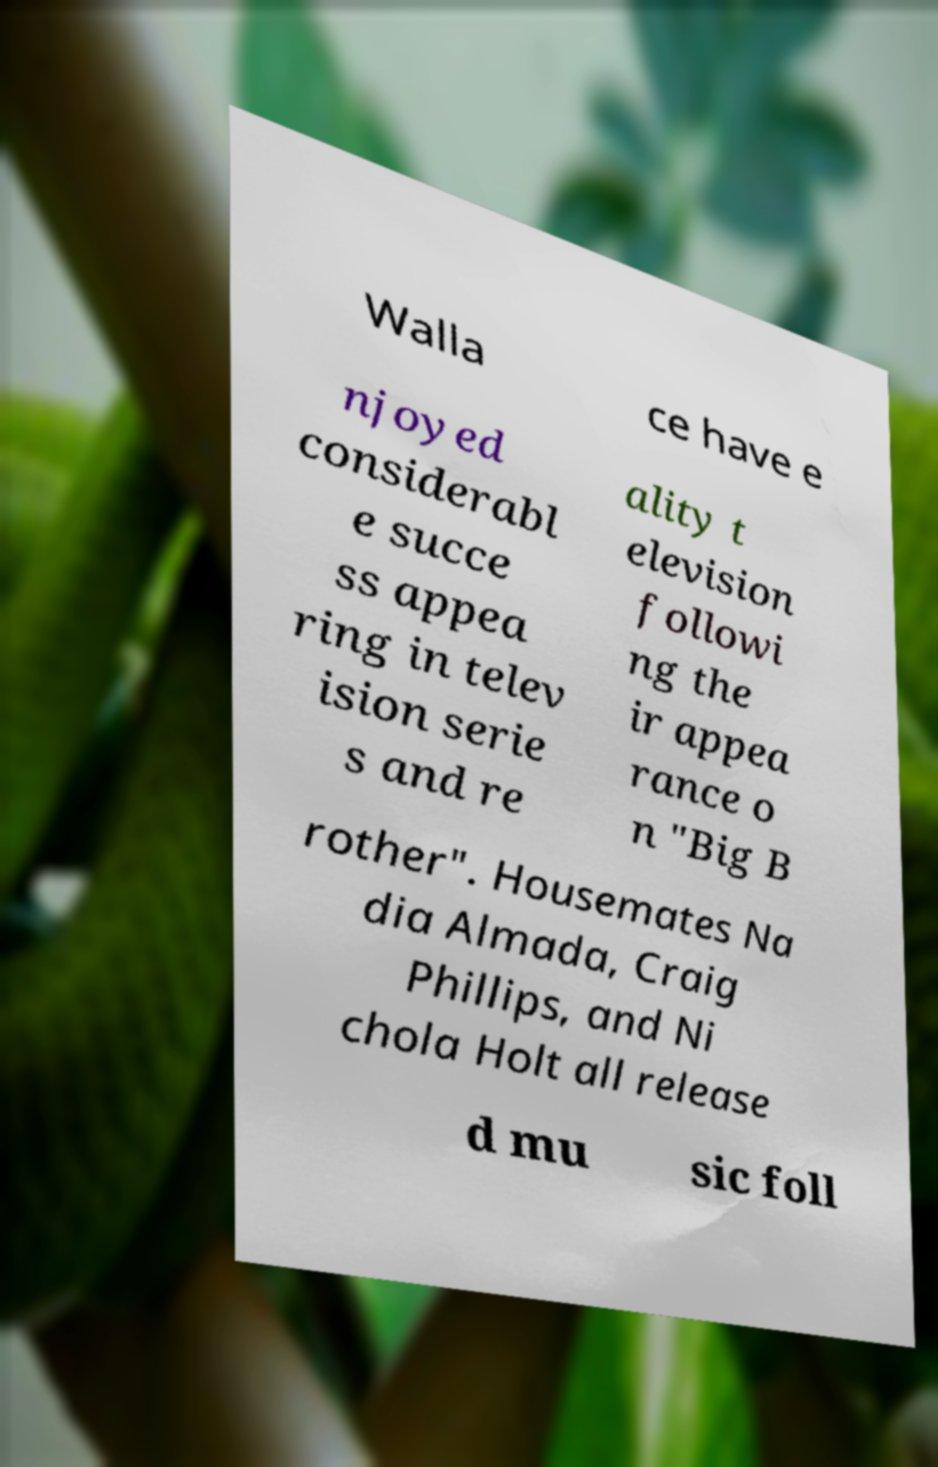What messages or text are displayed in this image? I need them in a readable, typed format. Walla ce have e njoyed considerabl e succe ss appea ring in telev ision serie s and re ality t elevision followi ng the ir appea rance o n "Big B rother". Housemates Na dia Almada, Craig Phillips, and Ni chola Holt all release d mu sic foll 